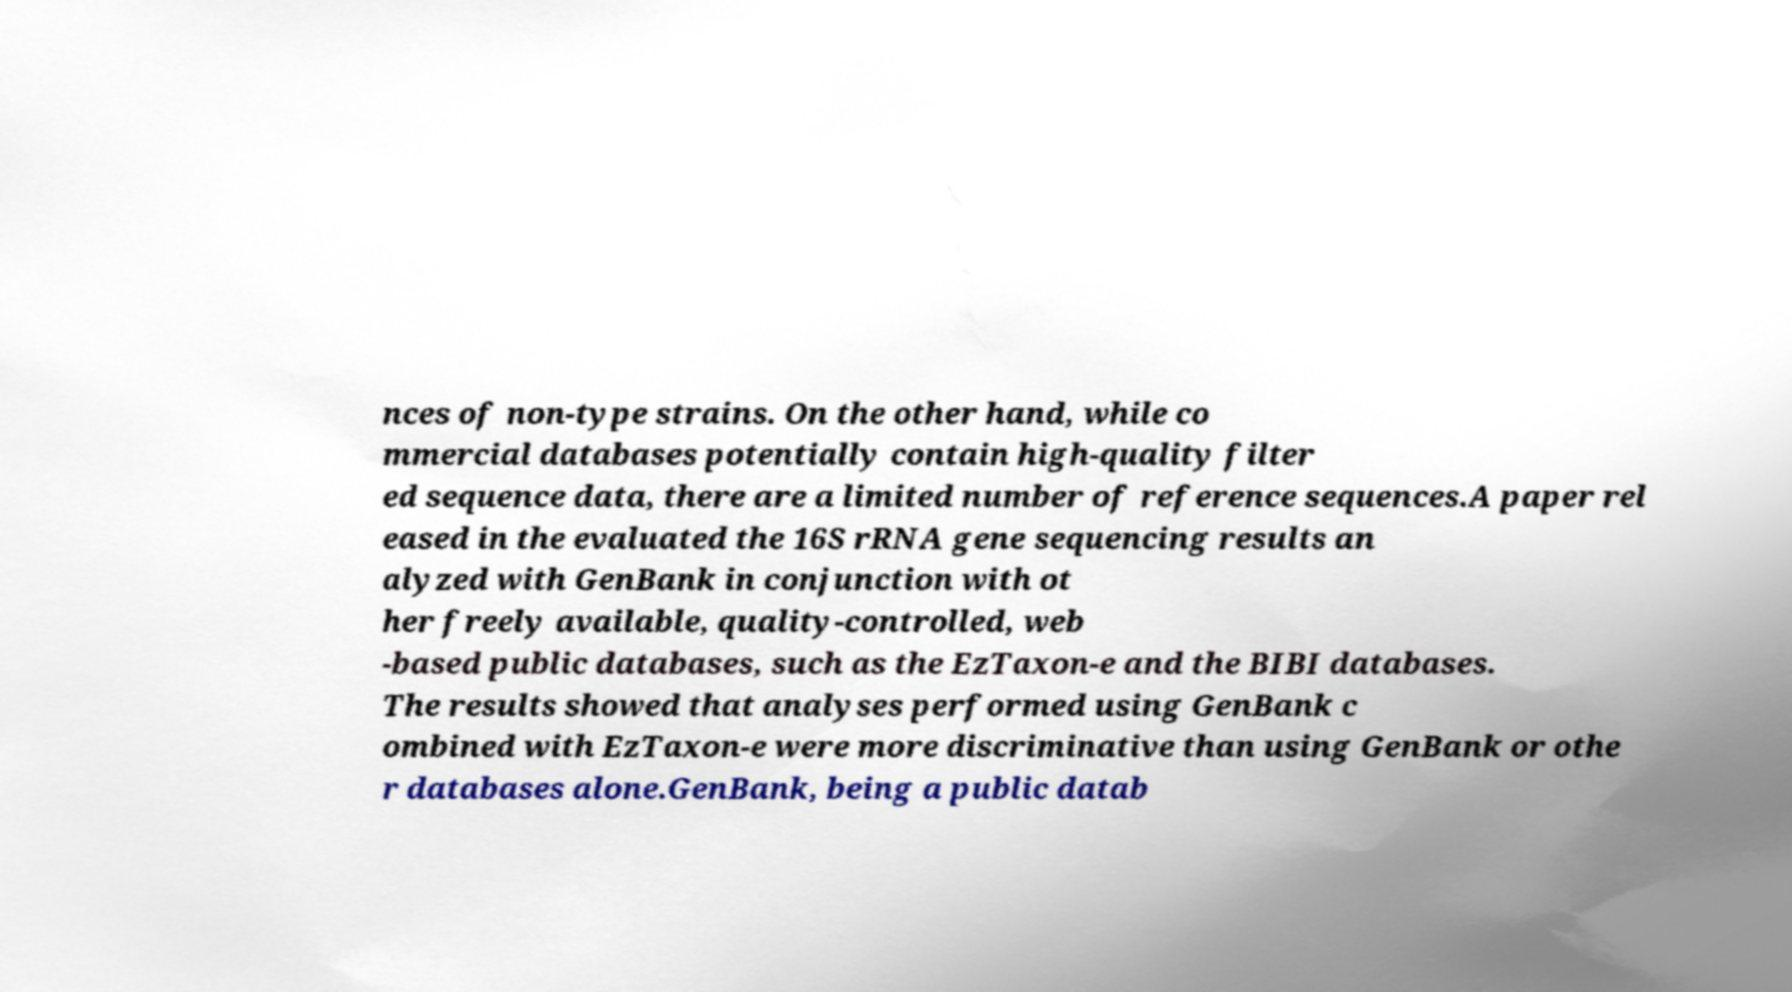For documentation purposes, I need the text within this image transcribed. Could you provide that? nces of non-type strains. On the other hand, while co mmercial databases potentially contain high-quality filter ed sequence data, there are a limited number of reference sequences.A paper rel eased in the evaluated the 16S rRNA gene sequencing results an alyzed with GenBank in conjunction with ot her freely available, quality-controlled, web -based public databases, such as the EzTaxon-e and the BIBI databases. The results showed that analyses performed using GenBank c ombined with EzTaxon-e were more discriminative than using GenBank or othe r databases alone.GenBank, being a public datab 